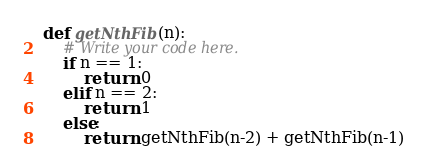Convert code to text. <code><loc_0><loc_0><loc_500><loc_500><_Python_>def getNthFib(n):
    # Write your code here.
	if n == 1:
		return 0
	elif n == 2:
		return 1
	else:
		return getNthFib(n-2) + getNthFib(n-1)</code> 